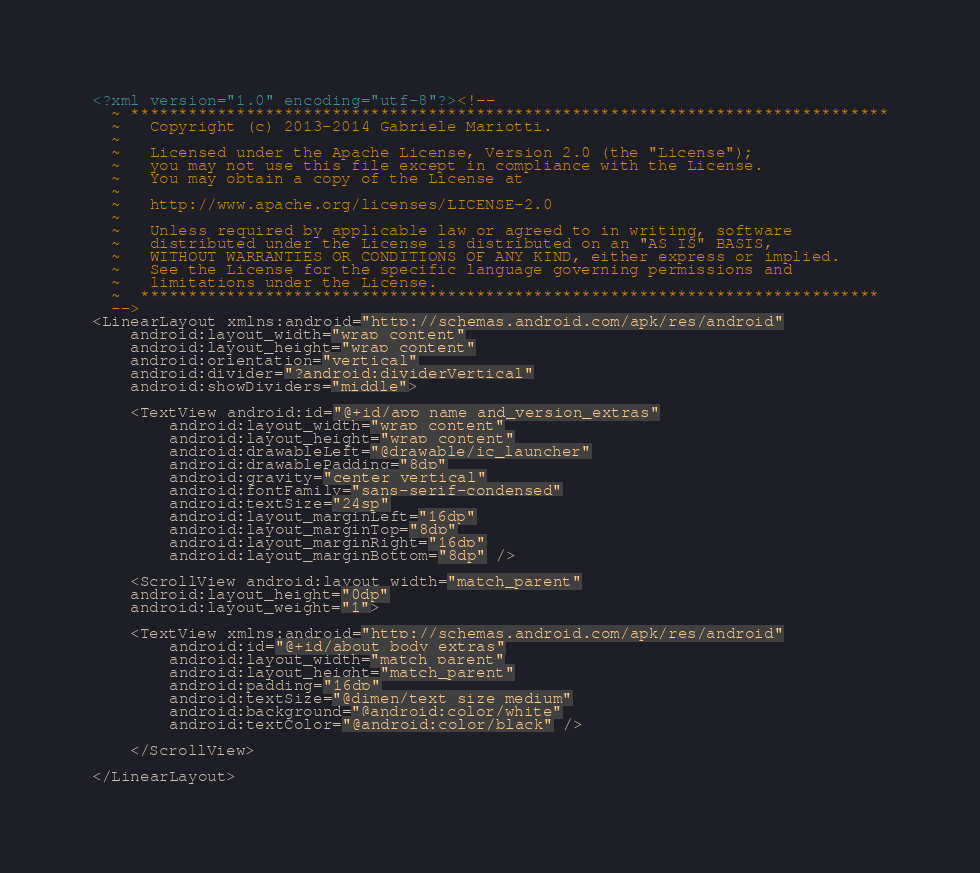Convert code to text. <code><loc_0><loc_0><loc_500><loc_500><_XML_><?xml version="1.0" encoding="utf-8"?><!--
  ~ *******************************************************************************
  ~   Copyright (c) 2013-2014 Gabriele Mariotti.
  ~
  ~   Licensed under the Apache License, Version 2.0 (the "License");
  ~   you may not use this file except in compliance with the License.
  ~   You may obtain a copy of the License at
  ~
  ~   http://www.apache.org/licenses/LICENSE-2.0
  ~
  ~   Unless required by applicable law or agreed to in writing, software
  ~   distributed under the License is distributed on an "AS IS" BASIS,
  ~   WITHOUT WARRANTIES OR CONDITIONS OF ANY KIND, either express or implied.
  ~   See the License for the specific language governing permissions and
  ~   limitations under the License.
  ~  *****************************************************************************
  -->
<LinearLayout xmlns:android="http://schemas.android.com/apk/res/android"
    android:layout_width="wrap_content"
    android:layout_height="wrap_content"
    android:orientation="vertical"
    android:divider="?android:dividerVertical"
    android:showDividers="middle">

    <TextView android:id="@+id/app_name_and_version_extras"
        android:layout_width="wrap_content"
        android:layout_height="wrap_content"
        android:drawableLeft="@drawable/ic_launcher"
        android:drawablePadding="8dp"
        android:gravity="center_vertical"
        android:fontFamily="sans-serif-condensed"
        android:textSize="24sp"
        android:layout_marginLeft="16dp"
        android:layout_marginTop="8dp"
        android:layout_marginRight="16dp"
        android:layout_marginBottom="8dp" />

    <ScrollView android:layout_width="match_parent"
    android:layout_height="0dp"
    android:layout_weight="1">

    <TextView xmlns:android="http://schemas.android.com/apk/res/android"
        android:id="@+id/about_body_extras"
        android:layout_width="match_parent"
        android:layout_height="match_parent"
        android:padding="16dp"
        android:textSize="@dimen/text_size_medium"
        android:background="@android:color/white"
        android:textColor="@android:color/black" />

    </ScrollView>

</LinearLayout></code> 